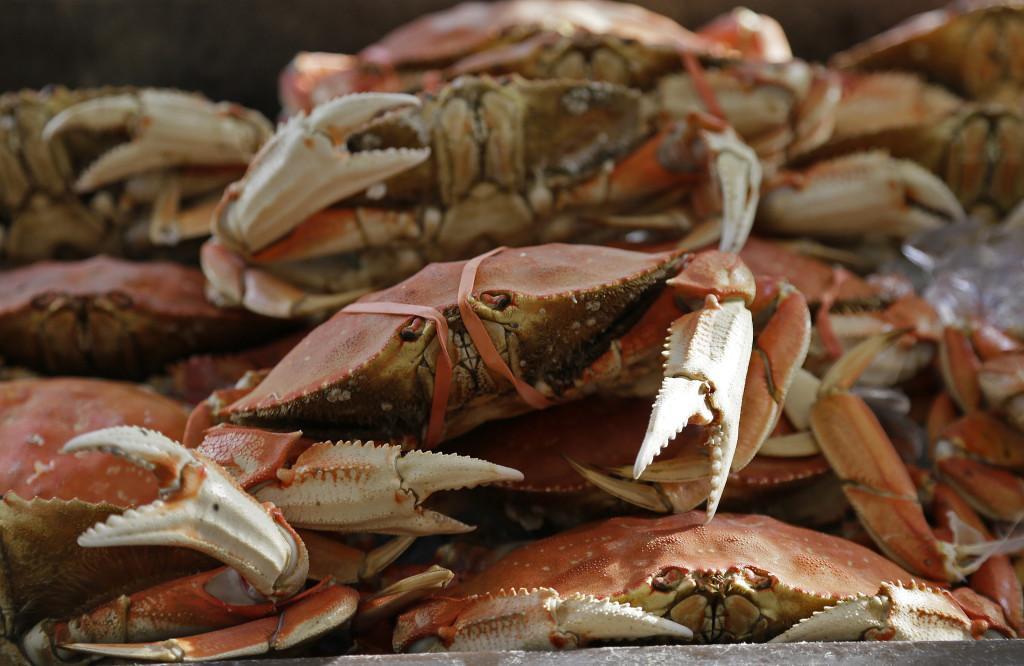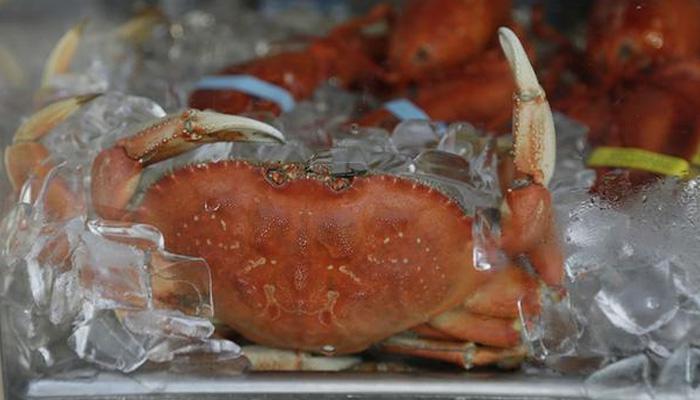The first image is the image on the left, the second image is the image on the right. For the images shown, is this caption "In the left image, a man in an apron is behind a counter containing piles of upside-down crabs." true? Answer yes or no. No. 